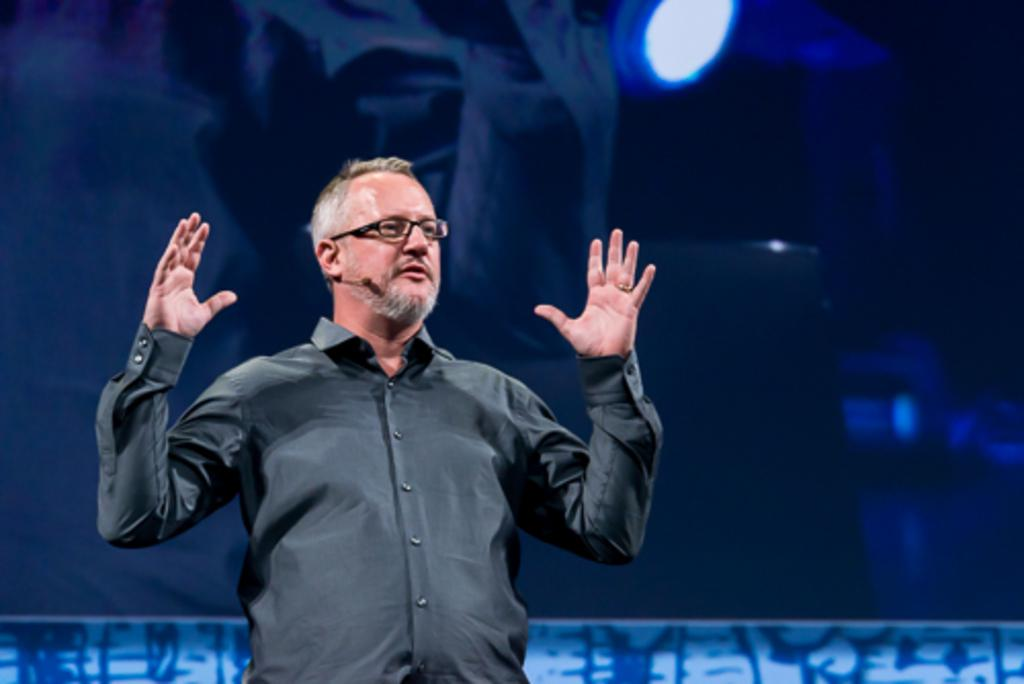What is present in the image? There is a man in the image. Can you describe the man's appearance? The man is wearing spectacles. What can be observed about the background of the image? The background of the image is blurred. How many brothers does the man have in the image? There is no information about the man's brothers in the image. What type of letters can be seen in the image? There are no letters visible in the image. Is there a balloon present in the image? There is no balloon present in the image. 